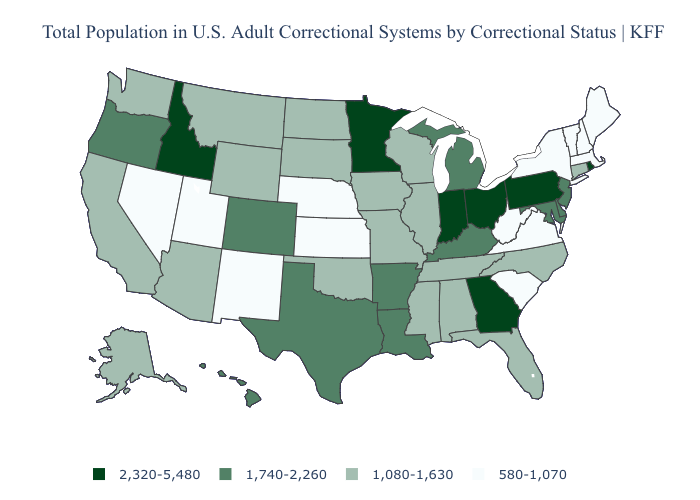Does the first symbol in the legend represent the smallest category?
Short answer required. No. Among the states that border Kentucky , which have the highest value?
Concise answer only. Indiana, Ohio. What is the lowest value in states that border Kansas?
Quick response, please. 580-1,070. Among the states that border Delaware , does Pennsylvania have the lowest value?
Answer briefly. No. What is the highest value in the Northeast ?
Write a very short answer. 2,320-5,480. Does Washington have a lower value than North Dakota?
Short answer required. No. What is the value of Illinois?
Give a very brief answer. 1,080-1,630. What is the value of Kansas?
Short answer required. 580-1,070. Name the states that have a value in the range 1,080-1,630?
Write a very short answer. Alabama, Alaska, Arizona, California, Connecticut, Florida, Illinois, Iowa, Mississippi, Missouri, Montana, North Carolina, North Dakota, Oklahoma, South Dakota, Tennessee, Washington, Wisconsin, Wyoming. What is the highest value in the USA?
Quick response, please. 2,320-5,480. What is the value of Pennsylvania?
Keep it brief. 2,320-5,480. Does Idaho have the highest value in the USA?
Write a very short answer. Yes. Does Louisiana have the highest value in the South?
Answer briefly. No. What is the value of Rhode Island?
Short answer required. 2,320-5,480. Among the states that border Louisiana , does Mississippi have the highest value?
Answer briefly. No. 